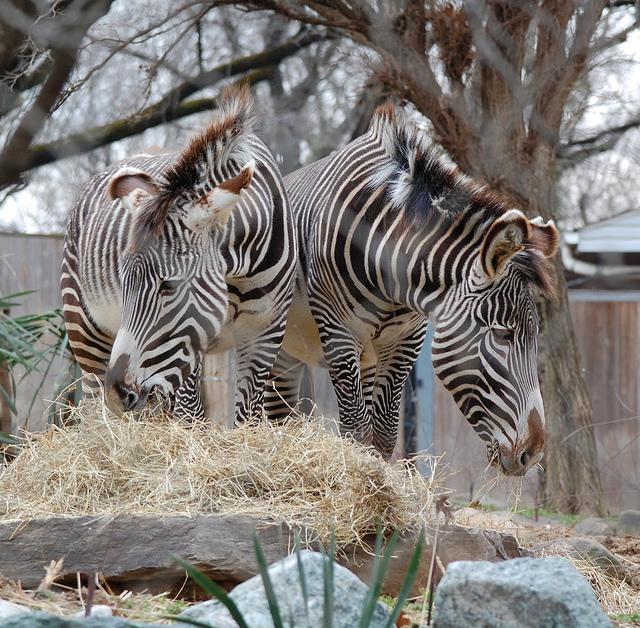Are these animals in captivity?
Keep it brief. Yes. How many zebras are there?
Quick response, please. 2. What type of animal is this?
Give a very brief answer. Zebra. How many zebras has there head lowered?
Answer briefly. 2. What are the zebras doing?
Give a very brief answer. Eating. 